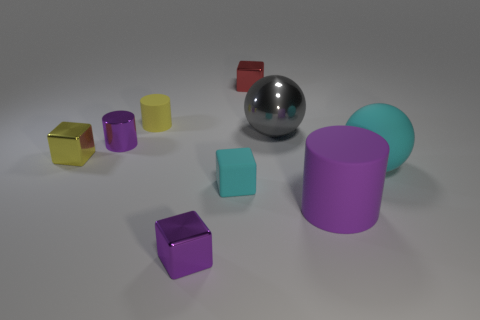There is a purple block; is its size the same as the purple cylinder that is right of the tiny purple cylinder? no 